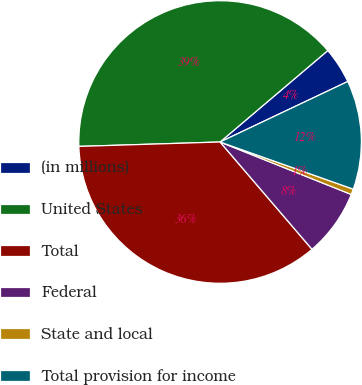Convert chart to OTSL. <chart><loc_0><loc_0><loc_500><loc_500><pie_chart><fcel>(in millions)<fcel>United States<fcel>Total<fcel>Federal<fcel>State and local<fcel>Total provision for income<nl><fcel>4.16%<fcel>39.3%<fcel>35.78%<fcel>7.67%<fcel>0.64%<fcel>12.46%<nl></chart> 